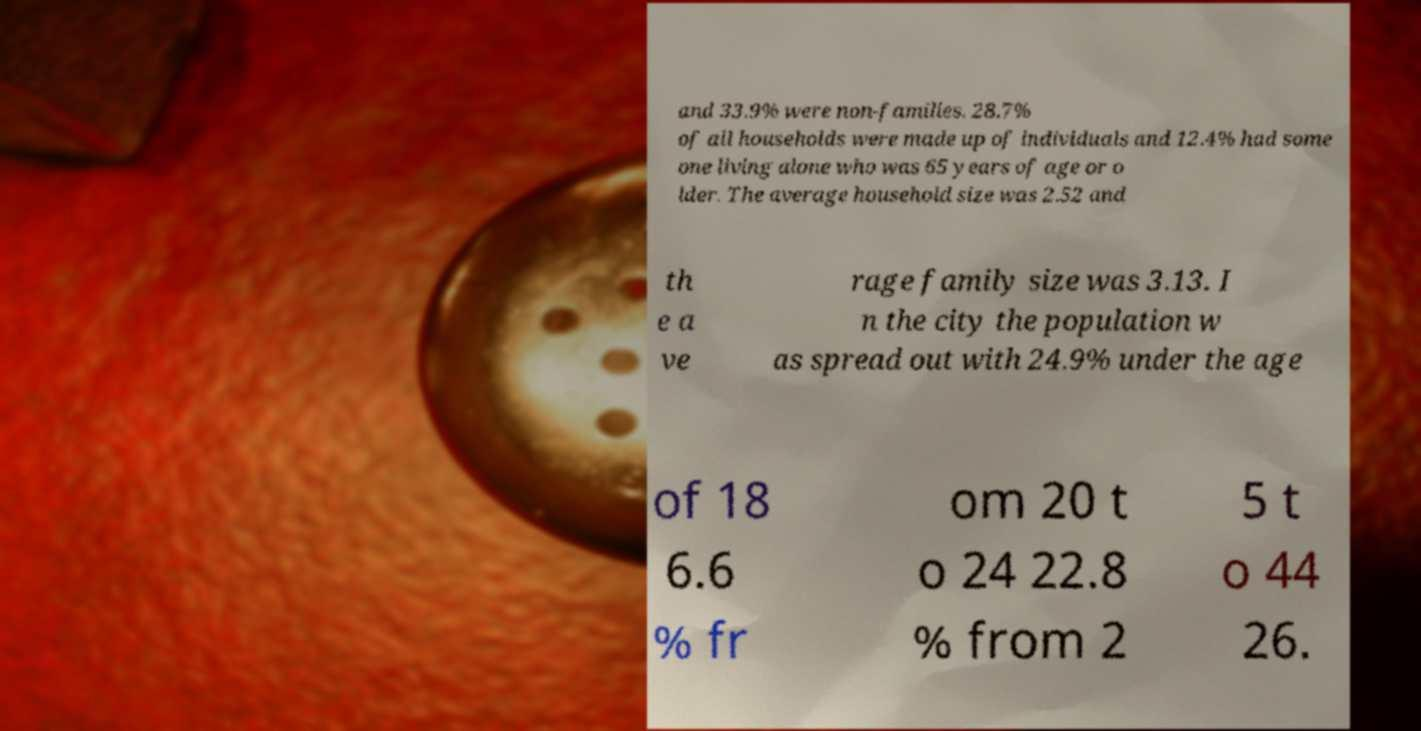Can you accurately transcribe the text from the provided image for me? and 33.9% were non-families. 28.7% of all households were made up of individuals and 12.4% had some one living alone who was 65 years of age or o lder. The average household size was 2.52 and th e a ve rage family size was 3.13. I n the city the population w as spread out with 24.9% under the age of 18 6.6 % fr om 20 t o 24 22.8 % from 2 5 t o 44 26. 